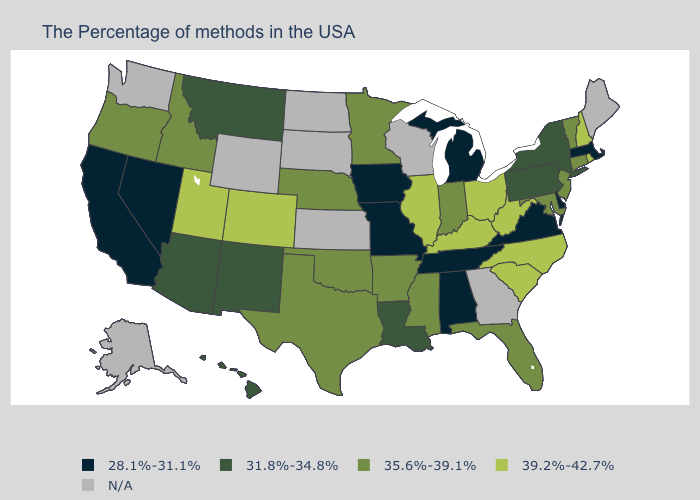What is the value of Nebraska?
Keep it brief. 35.6%-39.1%. What is the lowest value in the South?
Be succinct. 28.1%-31.1%. Is the legend a continuous bar?
Concise answer only. No. Name the states that have a value in the range 31.8%-34.8%?
Keep it brief. New York, Pennsylvania, Louisiana, New Mexico, Montana, Arizona, Hawaii. Among the states that border South Dakota , does Minnesota have the lowest value?
Be succinct. No. Name the states that have a value in the range 31.8%-34.8%?
Concise answer only. New York, Pennsylvania, Louisiana, New Mexico, Montana, Arizona, Hawaii. Among the states that border California , which have the highest value?
Give a very brief answer. Oregon. Among the states that border Oklahoma , which have the lowest value?
Quick response, please. Missouri. What is the lowest value in states that border South Dakota?
Quick response, please. 28.1%-31.1%. What is the lowest value in the South?
Write a very short answer. 28.1%-31.1%. Does Vermont have the highest value in the Northeast?
Quick response, please. No. Name the states that have a value in the range 31.8%-34.8%?
Short answer required. New York, Pennsylvania, Louisiana, New Mexico, Montana, Arizona, Hawaii. What is the value of New Hampshire?
Keep it brief. 39.2%-42.7%. Name the states that have a value in the range 31.8%-34.8%?
Concise answer only. New York, Pennsylvania, Louisiana, New Mexico, Montana, Arizona, Hawaii. What is the highest value in states that border California?
Write a very short answer. 35.6%-39.1%. 